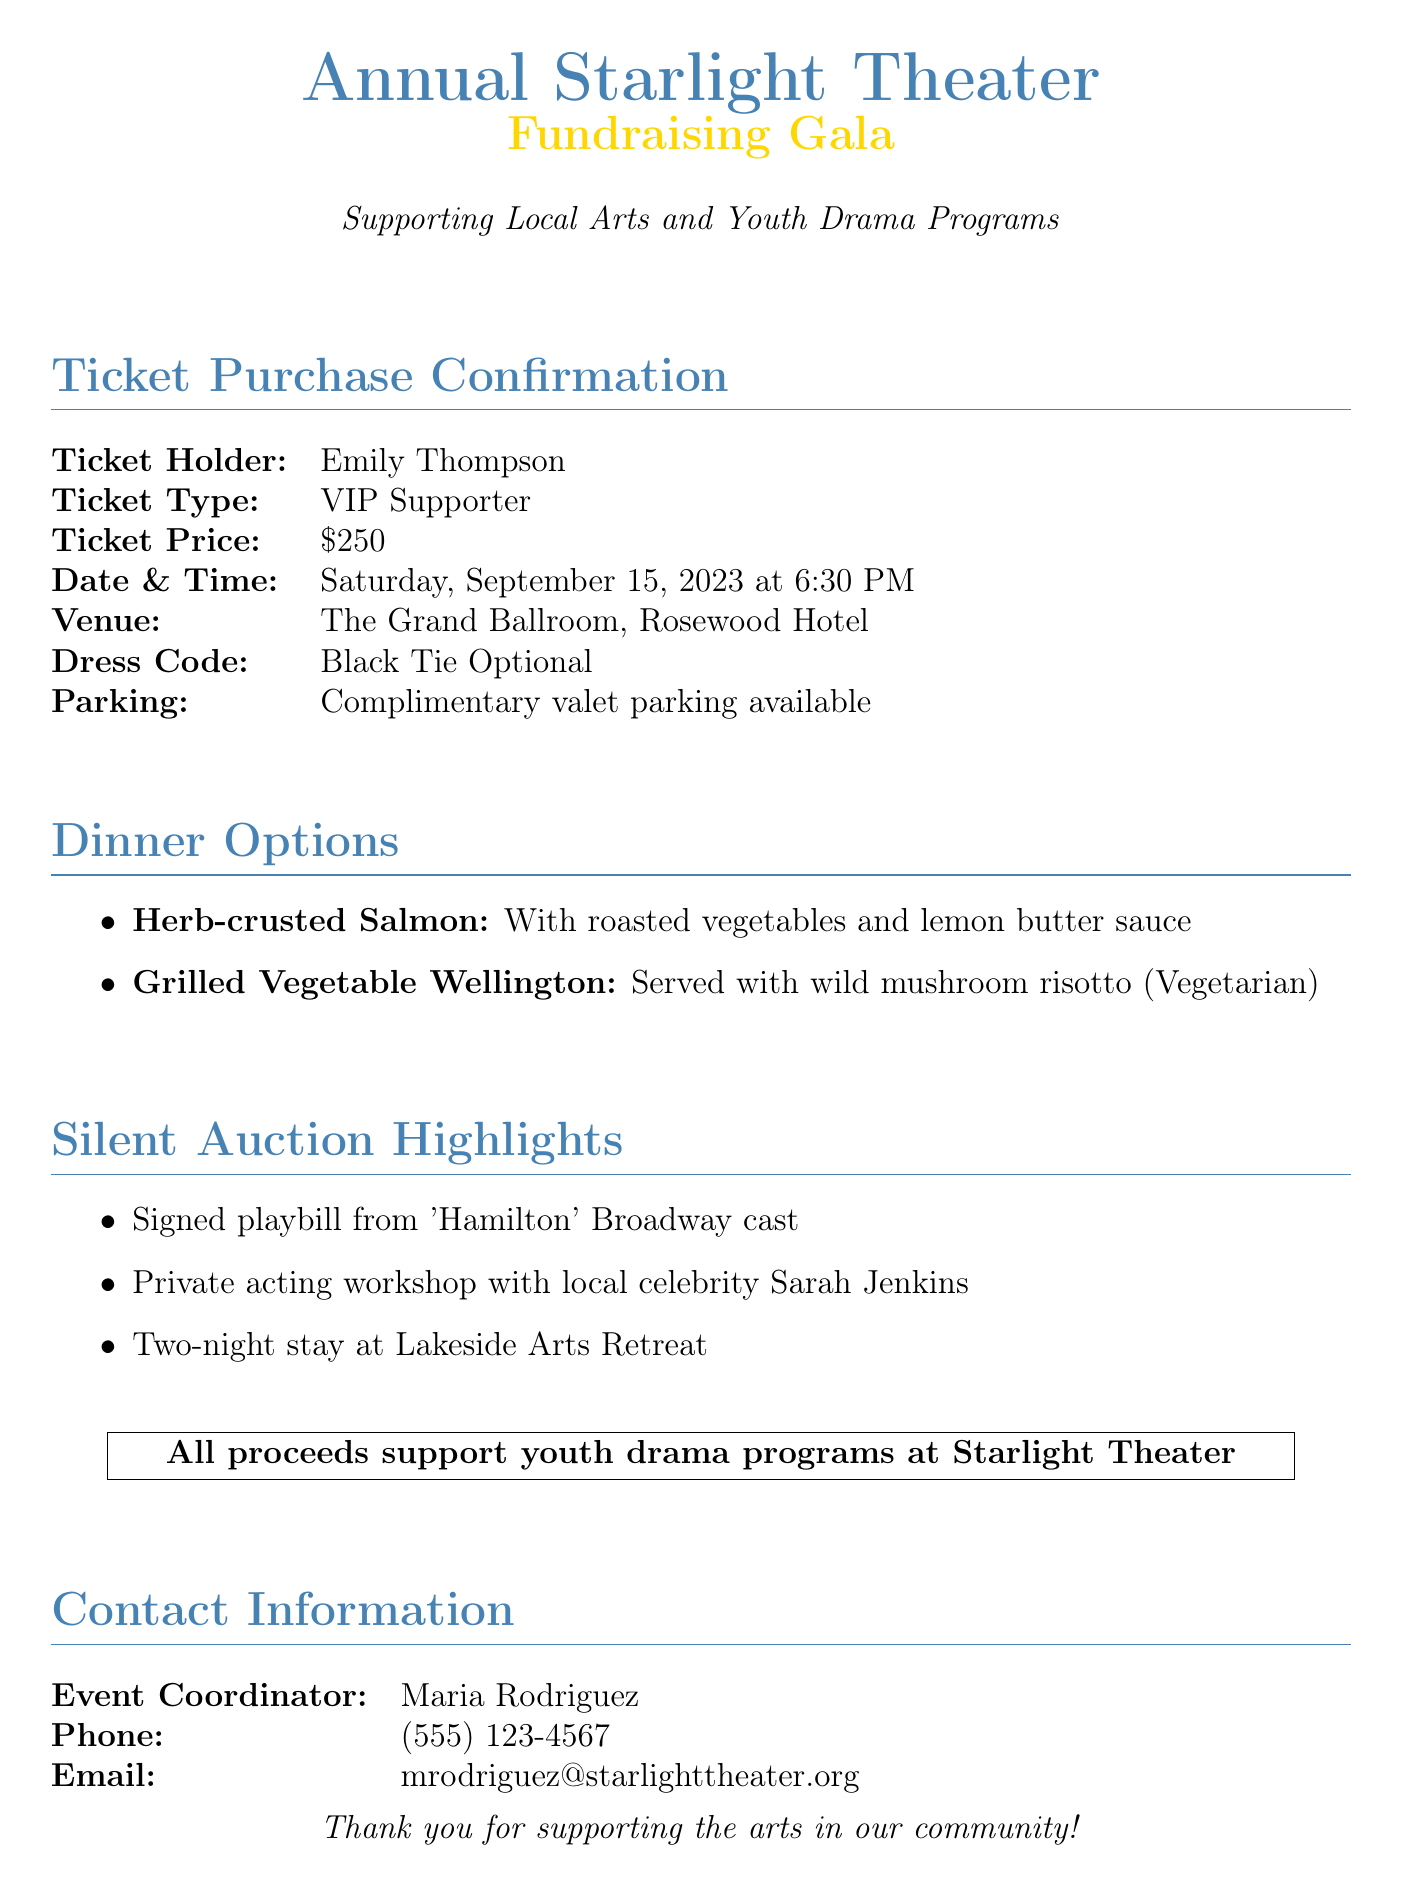What is the ticket holder's name? The ticket holder's name is mentioned in the document as Emily Thompson.
Answer: Emily Thompson What is the ticket price? The ticket price is specified in the document as $250.
Answer: $250 What are the dinner options offered? The document lists Herb-crusted Salmon and Grilled Vegetable Wellington as the dinner options.
Answer: Herb-crusted Salmon, Grilled Vegetable Wellington What is the date and time of the event? The event date and time are provided in the document as Saturday, September 15, 2023 at 6:30 PM.
Answer: Saturday, September 15, 2023 at 6:30 PM Who is the event coordinator? The event coordinator's name is mentioned in the document as Maria Rodriguez.
Answer: Maria Rodriguez What is one of the silent auction highlights? The document highlights a signed playbill from 'Hamilton' as one item in the silent auction.
Answer: Signed playbill from 'Hamilton' What type of dress code is specified? The dress code indicated in the document is Black Tie Optional.
Answer: Black Tie Optional Where is the venue located? The venue for the event is specified in the document as The Grand Ballroom, Rosewood Hotel.
Answer: The Grand Ballroom, Rosewood Hotel What is the purpose of the fundraising gala? The purpose of the gala, as indicated in the document, is to support local arts and youth drama programs.
Answer: Supporting local arts and youth drama programs 